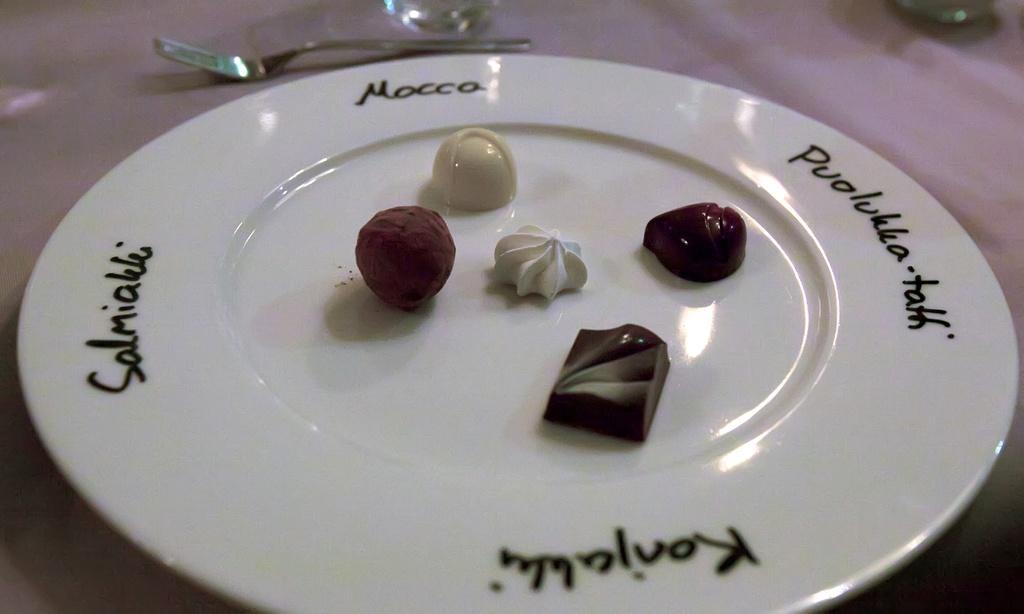What is present on the surface in the image? There is a plate in the image. What is on the plate? There are food items on the plate. Is there any text on the plate? Yes, there is text on the plate. What utensil is visible in the image? There is a fork in the image. Can you describe the unspecified object at the top of the image? Unfortunately, the facts provided do not give any information about the object at the top of the image. What impulse does the pet have in the image? There is no pet present in the image, so it is not possible to determine any impulses. 